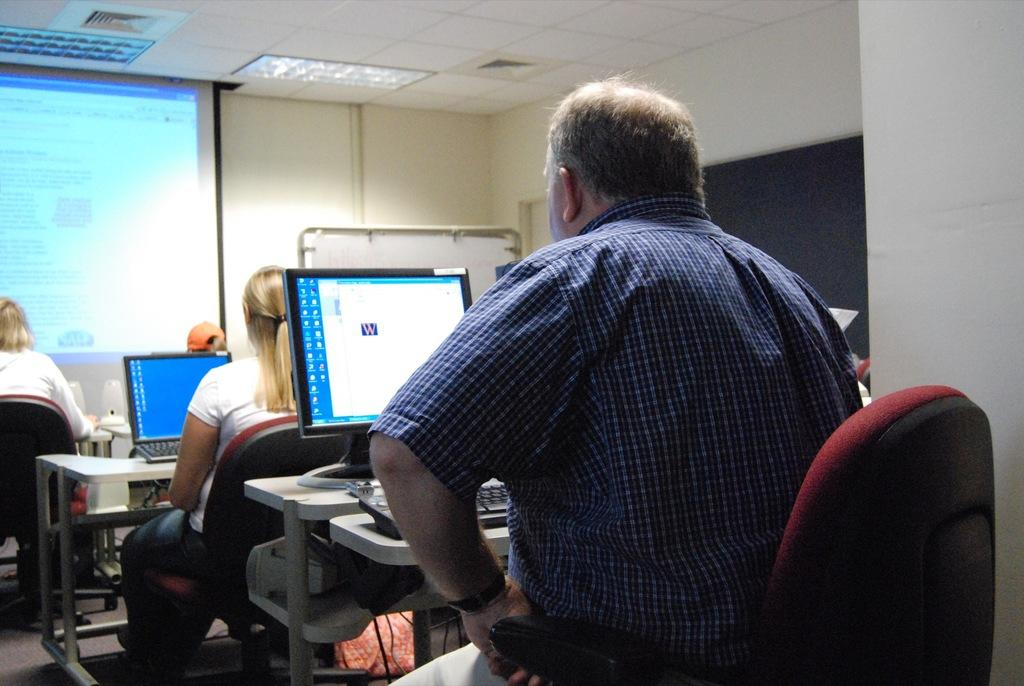What are the people in the image doing? The people in the image are sitting in chairs and working with desktops in front of them. Can you describe the setting of the image? The setting of the image is an office or workspace, as indicated by the presence of desktops and chairs. What type of secretary bird can be seen in the image? There is no secretary bird present in the image; it features people sitting in chairs and working with desktops. 